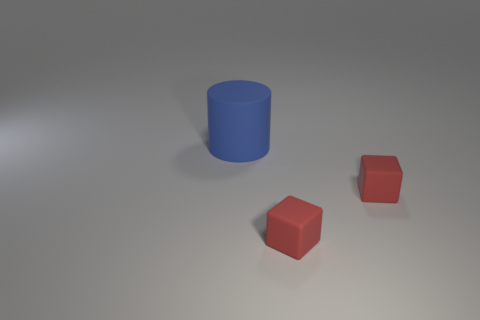Are any blue cylinders visible?
Your answer should be compact. Yes. What number of matte cylinders are the same color as the large thing?
Provide a short and direct response. 0. How many small objects are either red things or blue matte things?
Your response must be concise. 2. Is there another cylinder that has the same material as the big blue cylinder?
Provide a short and direct response. No. How many shiny things are either big green cylinders or large blue objects?
Offer a very short reply. 0. What number of other objects are the same shape as the large blue rubber object?
Give a very brief answer. 0. Are there more blue rubber things than small purple metallic cylinders?
Your answer should be very brief. Yes. How many objects are either big blue matte things or things that are to the right of the cylinder?
Give a very brief answer. 3. What number of other objects are there of the same size as the blue rubber cylinder?
Provide a succinct answer. 0. Is the number of blocks that are to the right of the big object greater than the number of tiny green spheres?
Your answer should be compact. Yes. 